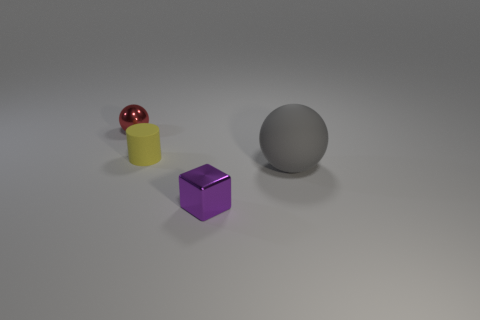Add 4 small cylinders. How many objects exist? 8 Subtract all cylinders. How many objects are left? 3 Subtract all gray rubber objects. Subtract all tiny red shiny objects. How many objects are left? 2 Add 2 tiny red things. How many tiny red things are left? 3 Add 4 gray spheres. How many gray spheres exist? 5 Subtract 0 green balls. How many objects are left? 4 